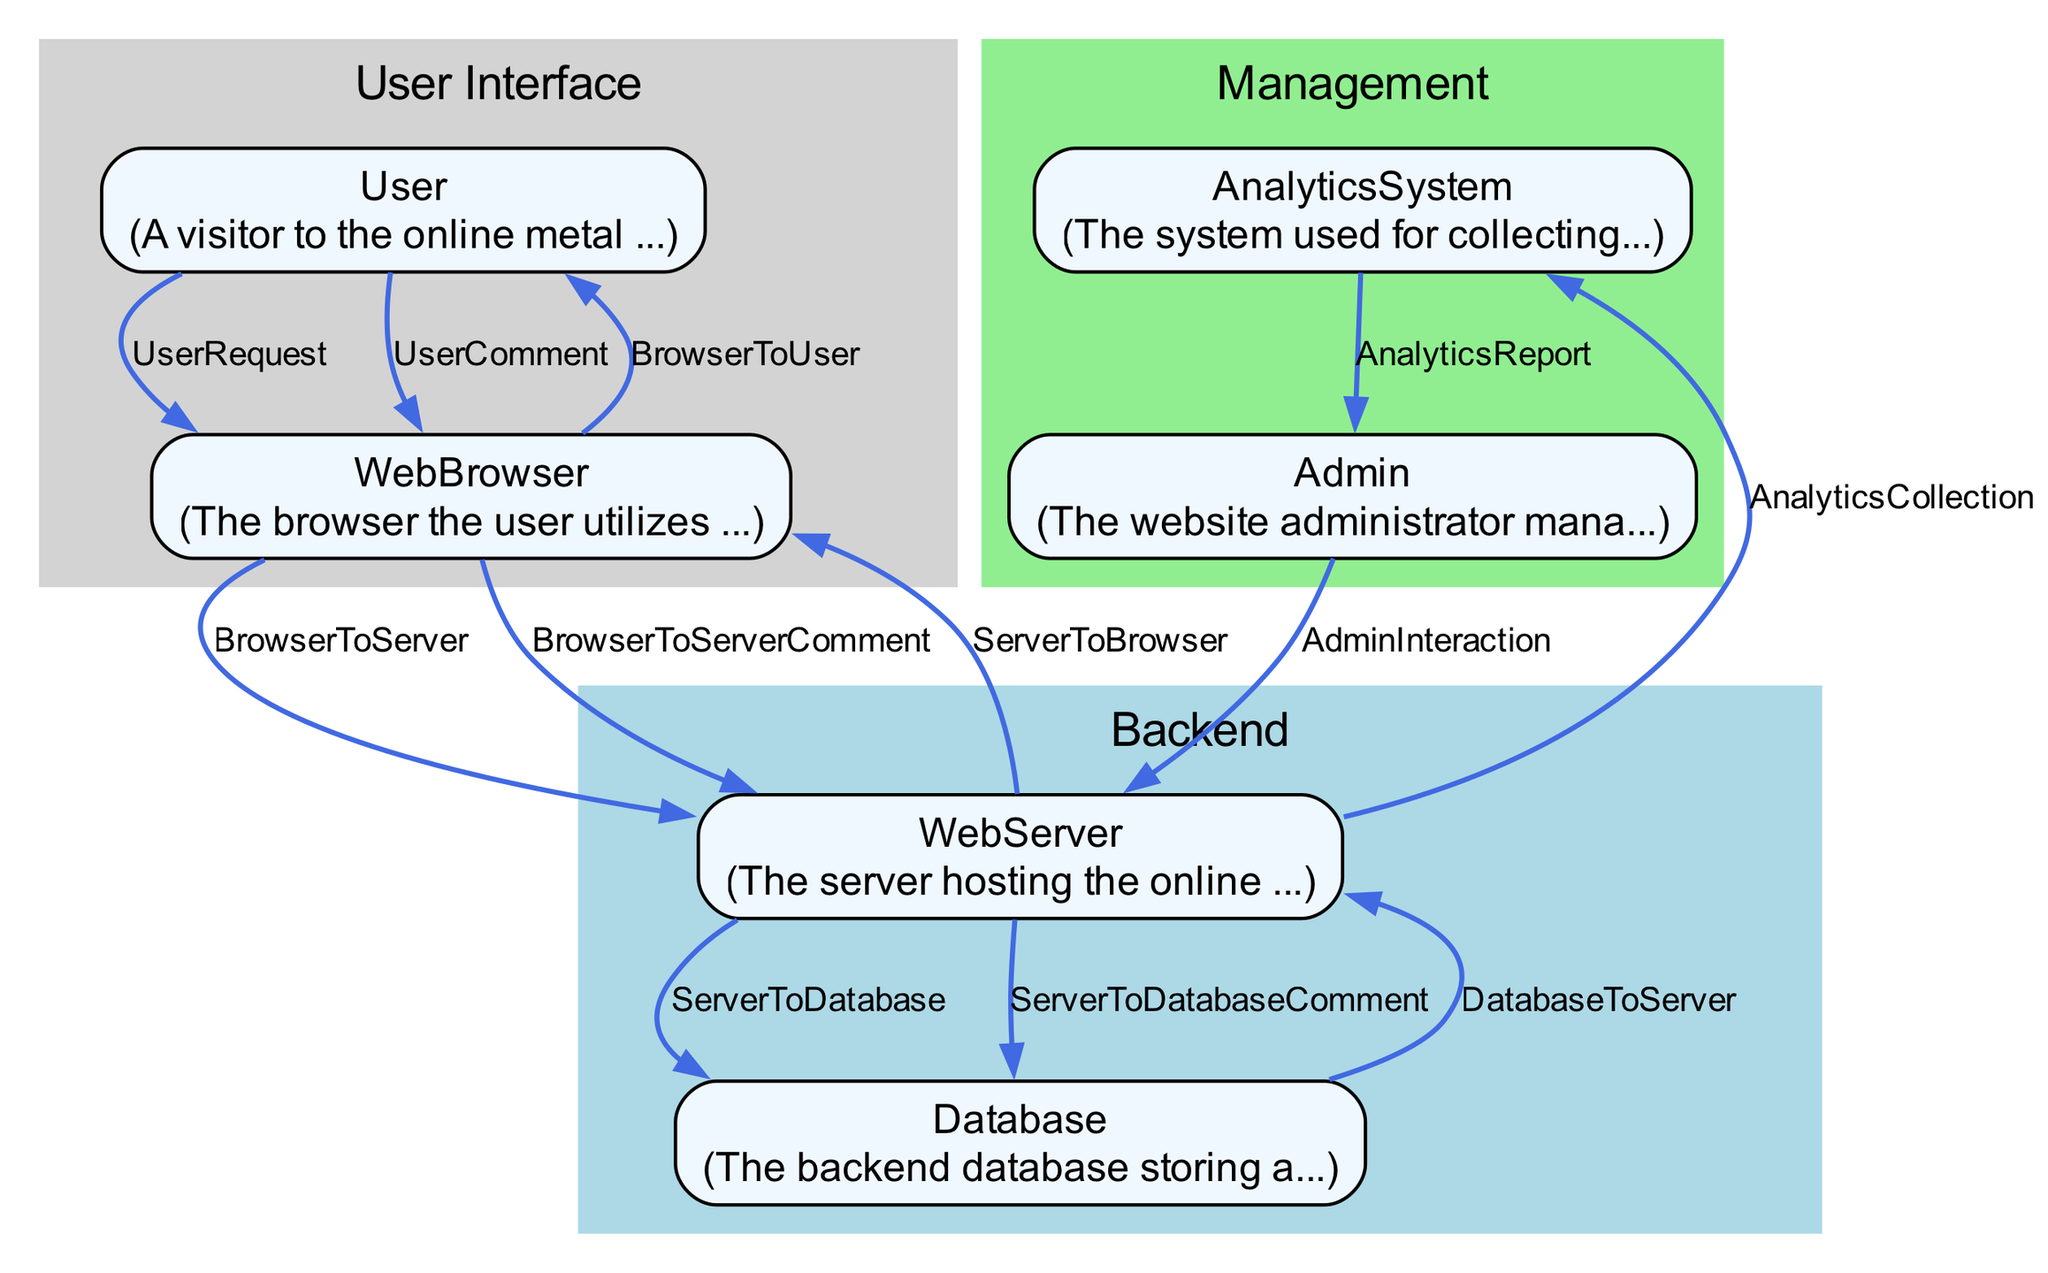What entities are involved in the user interaction process? The diagram lists six entities: User, WebBrowser, WebServer, Database, AnalyticsSystem, and Admin, all of which play a role in the user interaction process.
Answer: User, WebBrowser, WebServer, Database, AnalyticsSystem, Admin How many data flows originate from the User? By examining the diagram, it can be observed that the User has three outgoing data flows: UserRequest, UserComment, and interactions with the WebBrowser.
Answer: Three What does the WebBrowser do after receiving a response from the WebServer? Following the interaction flow, the WebBrowser renders the requested content for the User after receiving the response from the WebServer.
Answer: Renders content Which entity is responsible for generating analytics reports? The AnalyticsSystem is the entity that generates reports based on the data it collects and processes from user interactions and traffic data.
Answer: AnalyticsSystem Which two entities are clustered under the backend category? By looking at the clustering in the diagram, it is clear that the WebServer and Database are grouped together under the backend category.
Answer: WebServer, Database What action does the Admin perform with respect to user comments? The Admin reviews comments, which reflects their role in managing the content and engaging with user input on the online platform.
Answer: ReviewComments Which data flow indicates the storage of user comments in the database? The data flow labeled ServerToDatabaseComment represents the action of the web server storing user comments into the database after they have been submitted through the web browser.
Answer: ServerToDatabaseComment What is the direction of flow from the Database to the WebServer? The flow direction from the Database to the WebServer is represented in the diagram, showing that the database sends the requested content back to the web server during user interactions.
Answer: Database to WebServer 